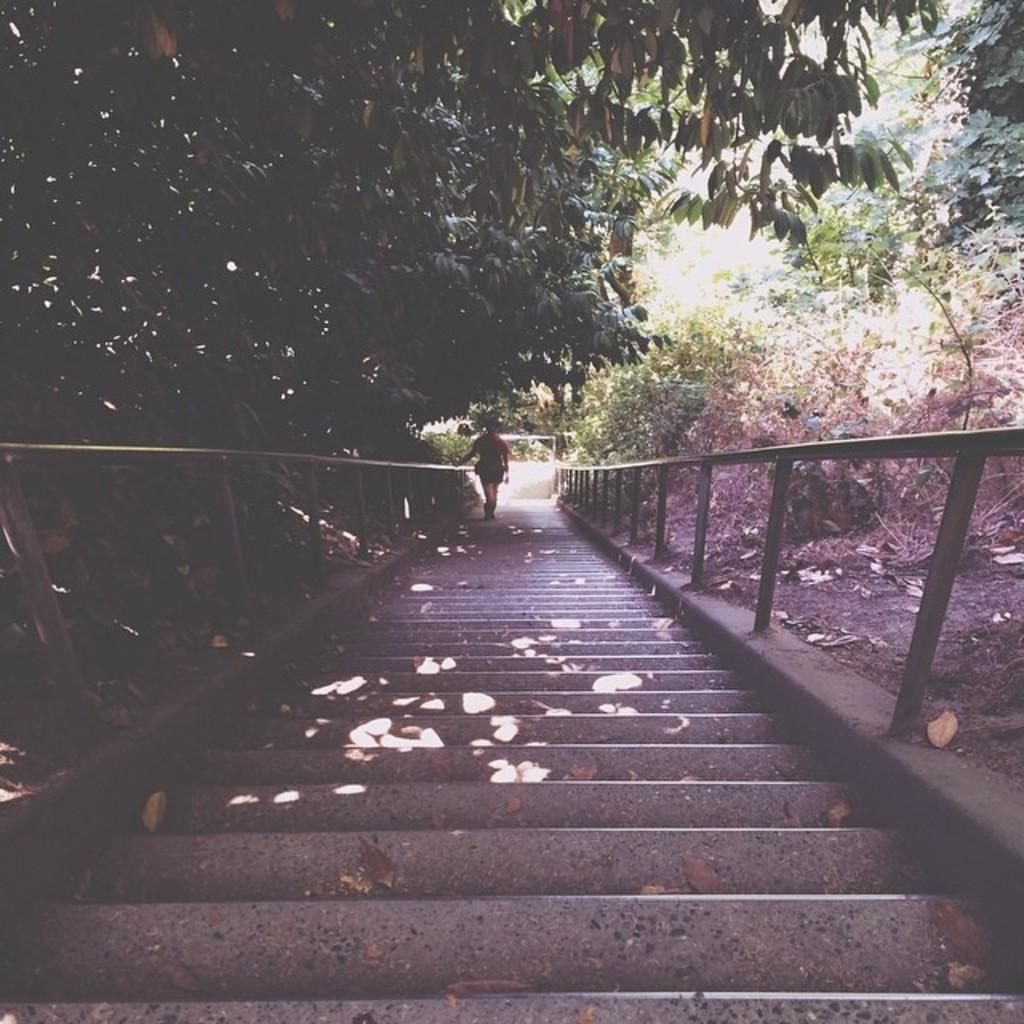What is the person in the image doing? The person is standing on a staircase in the image. What can be seen in the background of the image? There is a metal barricade and a group of trees in the background of the image. What type of respect can be seen being given to the substance in the image? There is no substance or respect present in the image; it only features a person standing on a staircase and a background with a metal barricade and trees. 